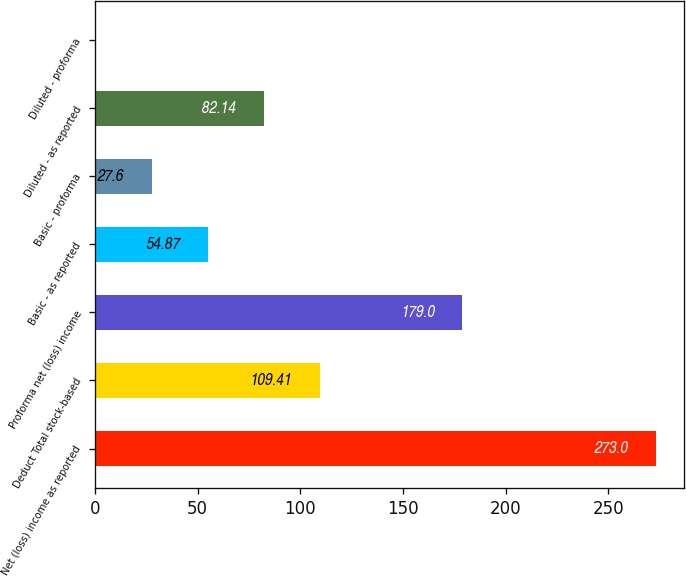<chart> <loc_0><loc_0><loc_500><loc_500><bar_chart><fcel>Net (loss) income as reported<fcel>Deduct Total stock-based<fcel>Proforma net (loss) income<fcel>Basic - as reported<fcel>Basic - proforma<fcel>Diluted - as reported<fcel>Diluted - proforma<nl><fcel>273<fcel>109.41<fcel>179<fcel>54.87<fcel>27.6<fcel>82.14<fcel>0.33<nl></chart> 